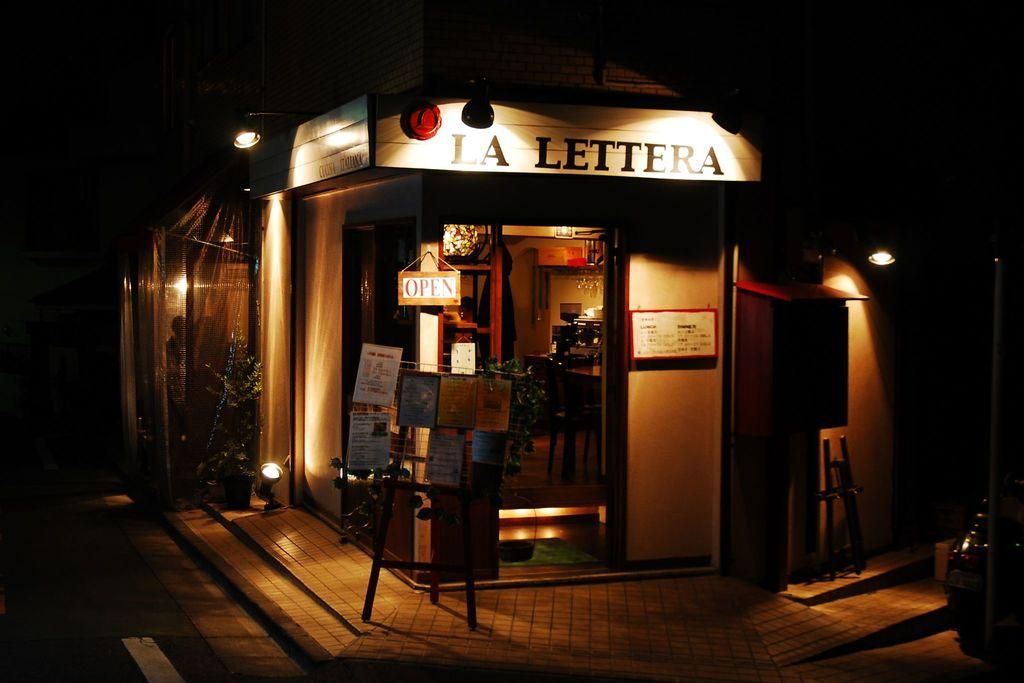<image>
Render a clear and concise summary of the photo. The storefront of Lat Lettera with an Open sign 